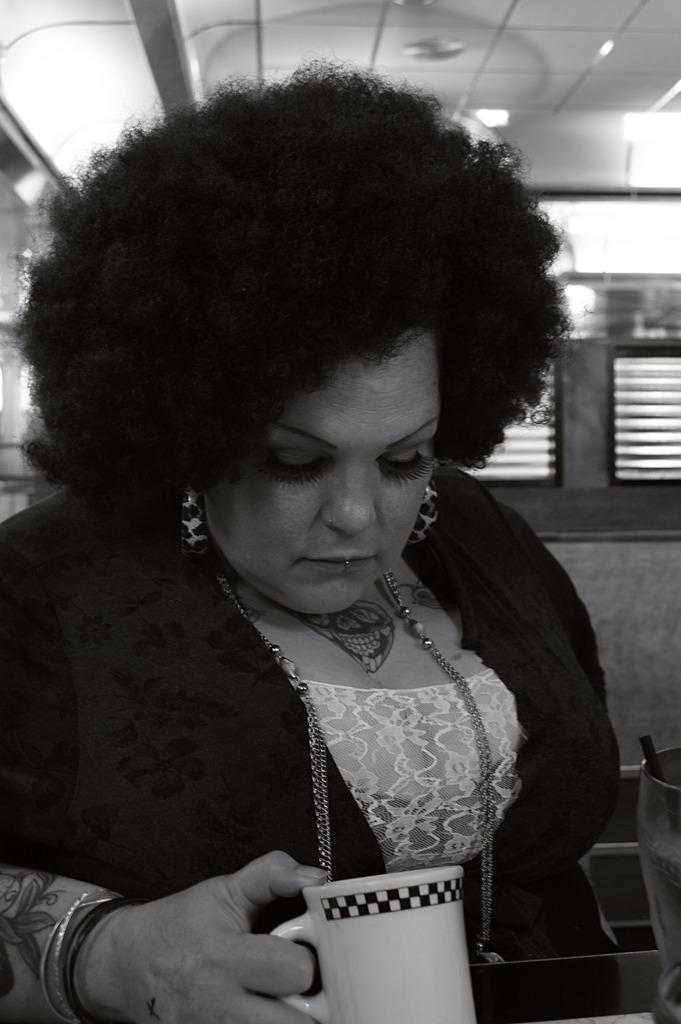Could you give a brief overview of what you see in this image? It is a black and white picture taken in a room where one woman is present and holding a cup in her hands and behind her there is wall with windows. 